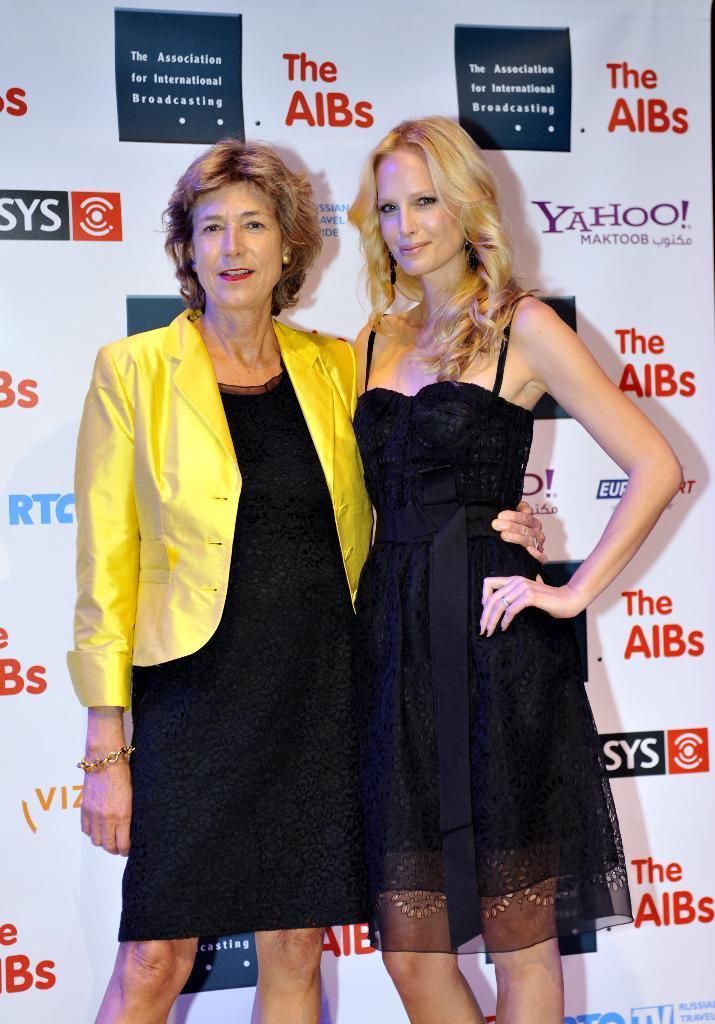In one or two sentences, can you explain what this image depicts? In this image I can see a woman wearing black and yellow colored dress and another woman wearing black color dress are standing. In the background I can see a huge banner which is white in color. 